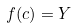Convert formula to latex. <formula><loc_0><loc_0><loc_500><loc_500>f ( c ) = Y</formula> 